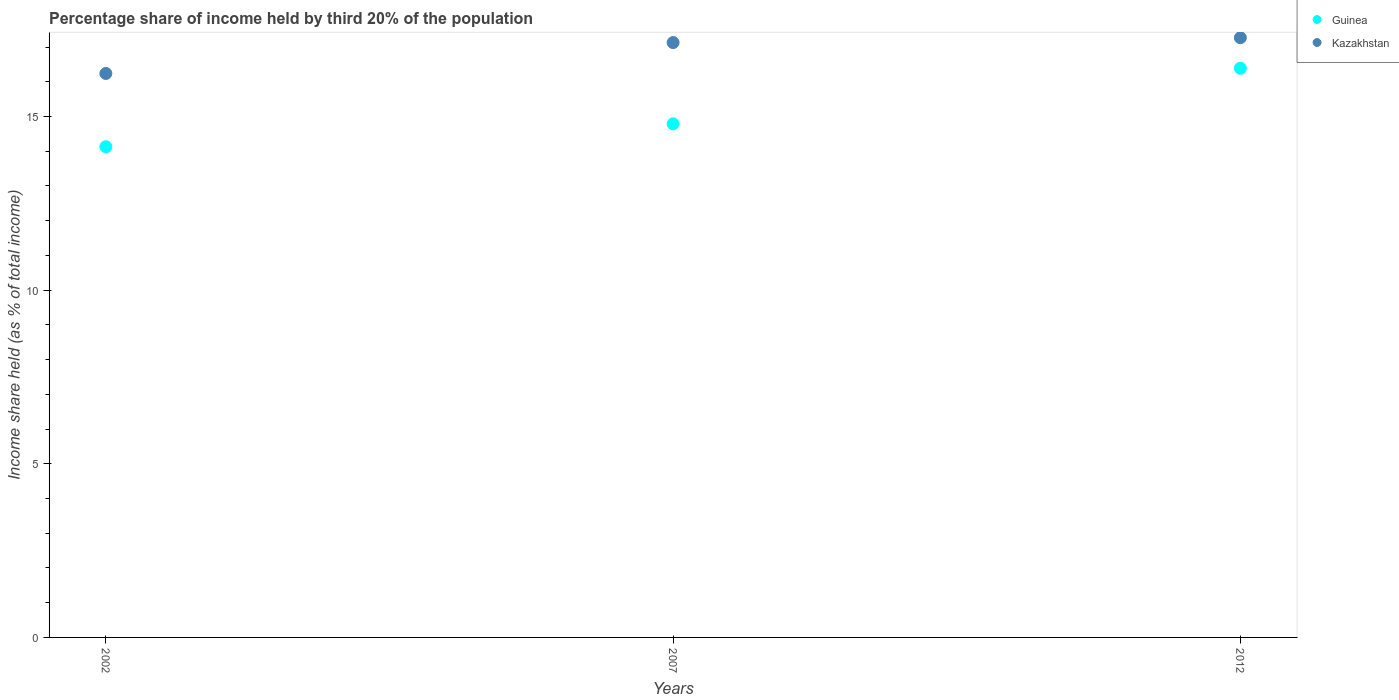How many different coloured dotlines are there?
Offer a very short reply. 2. What is the share of income held by third 20% of the population in Kazakhstan in 2012?
Ensure brevity in your answer.  17.27. Across all years, what is the maximum share of income held by third 20% of the population in Guinea?
Your answer should be compact. 16.39. Across all years, what is the minimum share of income held by third 20% of the population in Kazakhstan?
Offer a very short reply. 16.24. In which year was the share of income held by third 20% of the population in Kazakhstan minimum?
Keep it short and to the point. 2002. What is the total share of income held by third 20% of the population in Guinea in the graph?
Keep it short and to the point. 45.31. What is the difference between the share of income held by third 20% of the population in Kazakhstan in 2002 and that in 2012?
Keep it short and to the point. -1.03. What is the difference between the share of income held by third 20% of the population in Guinea in 2002 and the share of income held by third 20% of the population in Kazakhstan in 2012?
Make the answer very short. -3.14. What is the average share of income held by third 20% of the population in Guinea per year?
Make the answer very short. 15.1. In the year 2012, what is the difference between the share of income held by third 20% of the population in Guinea and share of income held by third 20% of the population in Kazakhstan?
Provide a short and direct response. -0.88. What is the ratio of the share of income held by third 20% of the population in Guinea in 2002 to that in 2012?
Ensure brevity in your answer.  0.86. Is the share of income held by third 20% of the population in Guinea in 2007 less than that in 2012?
Give a very brief answer. Yes. What is the difference between the highest and the second highest share of income held by third 20% of the population in Guinea?
Your response must be concise. 1.6. What is the difference between the highest and the lowest share of income held by third 20% of the population in Guinea?
Keep it short and to the point. 2.26. Is the share of income held by third 20% of the population in Guinea strictly less than the share of income held by third 20% of the population in Kazakhstan over the years?
Provide a short and direct response. Yes. How many years are there in the graph?
Provide a succinct answer. 3. What is the difference between two consecutive major ticks on the Y-axis?
Make the answer very short. 5. Does the graph contain any zero values?
Provide a succinct answer. No. Where does the legend appear in the graph?
Provide a short and direct response. Top right. What is the title of the graph?
Offer a terse response. Percentage share of income held by third 20% of the population. What is the label or title of the Y-axis?
Provide a short and direct response. Income share held (as % of total income). What is the Income share held (as % of total income) of Guinea in 2002?
Provide a succinct answer. 14.13. What is the Income share held (as % of total income) of Kazakhstan in 2002?
Offer a terse response. 16.24. What is the Income share held (as % of total income) in Guinea in 2007?
Provide a short and direct response. 14.79. What is the Income share held (as % of total income) of Kazakhstan in 2007?
Make the answer very short. 17.13. What is the Income share held (as % of total income) in Guinea in 2012?
Ensure brevity in your answer.  16.39. What is the Income share held (as % of total income) of Kazakhstan in 2012?
Ensure brevity in your answer.  17.27. Across all years, what is the maximum Income share held (as % of total income) in Guinea?
Your answer should be compact. 16.39. Across all years, what is the maximum Income share held (as % of total income) in Kazakhstan?
Your answer should be very brief. 17.27. Across all years, what is the minimum Income share held (as % of total income) in Guinea?
Make the answer very short. 14.13. Across all years, what is the minimum Income share held (as % of total income) of Kazakhstan?
Ensure brevity in your answer.  16.24. What is the total Income share held (as % of total income) in Guinea in the graph?
Offer a terse response. 45.31. What is the total Income share held (as % of total income) in Kazakhstan in the graph?
Offer a terse response. 50.64. What is the difference between the Income share held (as % of total income) of Guinea in 2002 and that in 2007?
Your answer should be very brief. -0.66. What is the difference between the Income share held (as % of total income) of Kazakhstan in 2002 and that in 2007?
Make the answer very short. -0.89. What is the difference between the Income share held (as % of total income) of Guinea in 2002 and that in 2012?
Offer a very short reply. -2.26. What is the difference between the Income share held (as % of total income) in Kazakhstan in 2002 and that in 2012?
Offer a terse response. -1.03. What is the difference between the Income share held (as % of total income) of Guinea in 2007 and that in 2012?
Keep it short and to the point. -1.6. What is the difference between the Income share held (as % of total income) in Kazakhstan in 2007 and that in 2012?
Keep it short and to the point. -0.14. What is the difference between the Income share held (as % of total income) in Guinea in 2002 and the Income share held (as % of total income) in Kazakhstan in 2012?
Keep it short and to the point. -3.14. What is the difference between the Income share held (as % of total income) in Guinea in 2007 and the Income share held (as % of total income) in Kazakhstan in 2012?
Offer a terse response. -2.48. What is the average Income share held (as % of total income) in Guinea per year?
Provide a succinct answer. 15.1. What is the average Income share held (as % of total income) of Kazakhstan per year?
Ensure brevity in your answer.  16.88. In the year 2002, what is the difference between the Income share held (as % of total income) of Guinea and Income share held (as % of total income) of Kazakhstan?
Your answer should be very brief. -2.11. In the year 2007, what is the difference between the Income share held (as % of total income) of Guinea and Income share held (as % of total income) of Kazakhstan?
Give a very brief answer. -2.34. In the year 2012, what is the difference between the Income share held (as % of total income) in Guinea and Income share held (as % of total income) in Kazakhstan?
Make the answer very short. -0.88. What is the ratio of the Income share held (as % of total income) of Guinea in 2002 to that in 2007?
Give a very brief answer. 0.96. What is the ratio of the Income share held (as % of total income) of Kazakhstan in 2002 to that in 2007?
Offer a very short reply. 0.95. What is the ratio of the Income share held (as % of total income) of Guinea in 2002 to that in 2012?
Offer a very short reply. 0.86. What is the ratio of the Income share held (as % of total income) in Kazakhstan in 2002 to that in 2012?
Provide a succinct answer. 0.94. What is the ratio of the Income share held (as % of total income) of Guinea in 2007 to that in 2012?
Make the answer very short. 0.9. What is the difference between the highest and the second highest Income share held (as % of total income) in Kazakhstan?
Make the answer very short. 0.14. What is the difference between the highest and the lowest Income share held (as % of total income) of Guinea?
Provide a succinct answer. 2.26. 